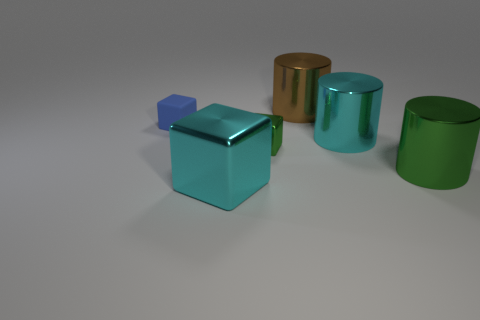What shape is the cyan metal object on the right side of the large thing that is to the left of the large brown cylinder that is behind the small green thing?
Ensure brevity in your answer.  Cylinder. There is a big cyan thing to the left of the brown object; is it the same shape as the object behind the blue block?
Offer a very short reply. No. What color is the large block?
Your answer should be compact. Cyan. There is a green block that is the same material as the large brown thing; what size is it?
Give a very brief answer. Small. Is there anything else that is the same color as the big metal block?
Keep it short and to the point. Yes. There is a tiny block that is in front of the tiny blue rubber cube; does it have the same color as the large cylinder that is in front of the tiny green thing?
Give a very brief answer. Yes. What color is the small object that is behind the tiny green metallic cube?
Ensure brevity in your answer.  Blue. There is a thing behind the blue object; is it the same size as the big cyan metal cylinder?
Offer a very short reply. Yes. Is the number of big shiny blocks less than the number of cubes?
Your answer should be very brief. Yes. There is a thing that is the same color as the big block; what shape is it?
Ensure brevity in your answer.  Cylinder. 